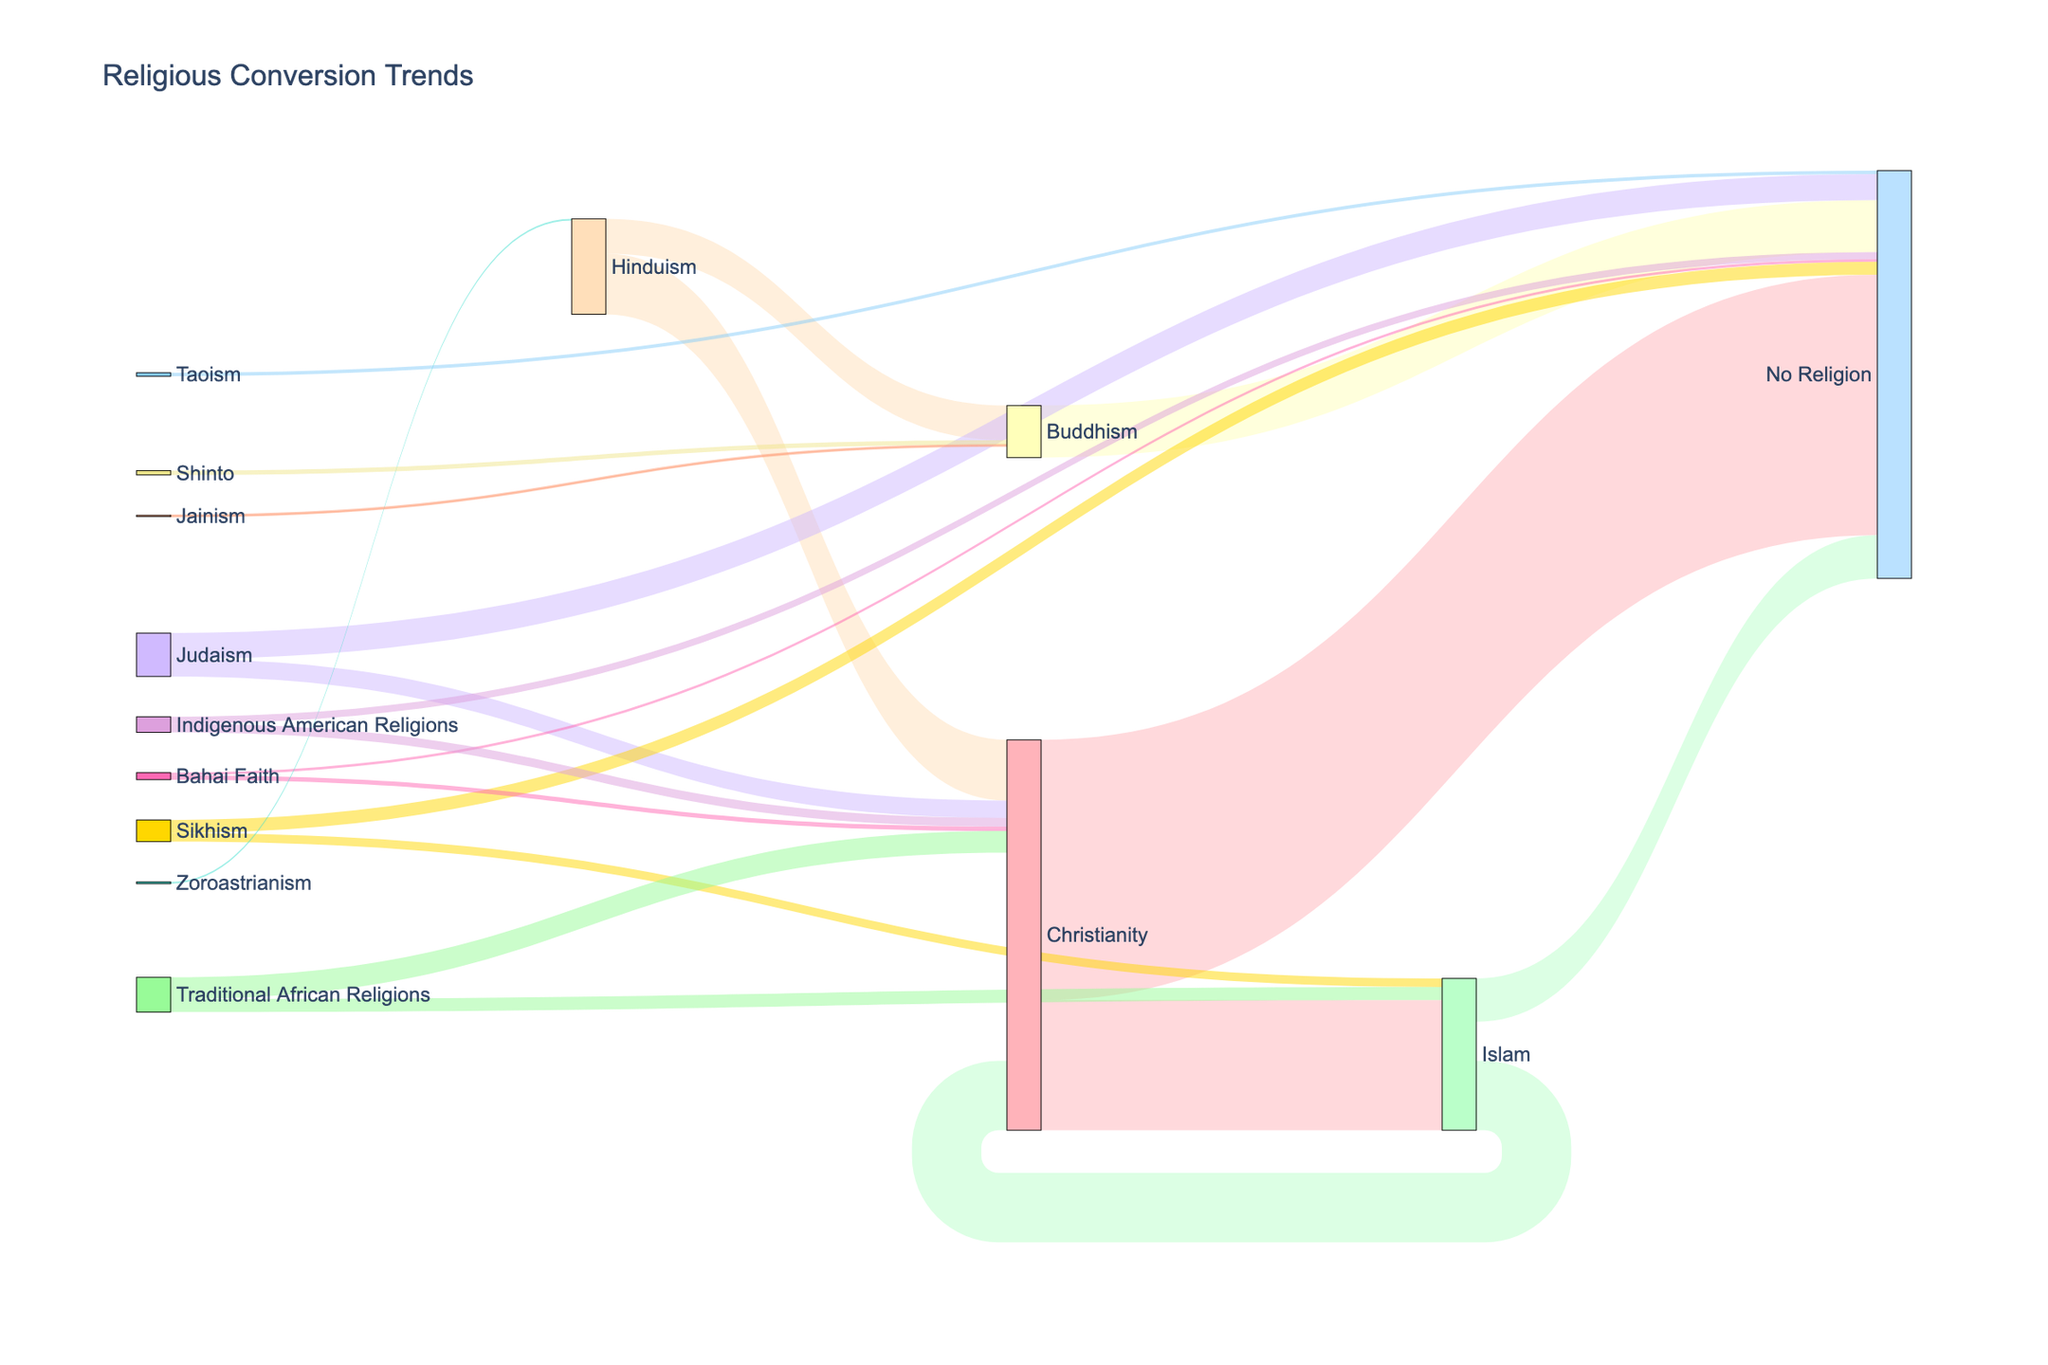What is the overall trend shown in the Sankey diagram? The Sankey diagram shows the flow of people converting from one religion to another. By analyzing the width of the lines (which represents the value of conversions), we can observe a significant trend of people leaving Christianity and Islam towards having "No Religion" as well as people moving within other religions like Buddhism and Zoroastrianism.
Answer: Conversions towards "No Religion" are prominent Which religion has the highest number of converts moving to "No Religion"? By looking at the width of the lines going to "No Religion", we see that Christianity has the highest number of people converting to "No Religion" because the line originating from Christianity to "No Religion" is the thickest.
Answer: Christianity How many people are converting from Islam to Christianity? Look at the width and the value labeled on the line flowing from Islam to Christianity. The figure shows that 80,000 people are converting from Islam to Christianity.
Answer: 80,000 Which religions have people converting to Buddhism? Analyze the diagram for lines that end at Buddhism. There are conversions from Hinduism, Shinto, and Jainism to Buddhism.
Answer: Hinduism, Shinto, Jainism What is the total number of people converting from Hinduism? To compute this, sum up all values of the outgoing lines from Hinduism. Hinduism has 70,000 converting to Christianity and 40,000 converting to Buddhism. The total is 70,000 + 40,000 = 110,000.
Answer: 110,000 Compare the number of people converting from Traditional African Religions to Christianity versus those converting to Islam. Inspect the widths and values of the lines moving from Traditional African Religions to Christianity and Islam. There are 25,000 converting to Christianity and 15,000 converting to Islam. 25,000 is greater than 15,000.
Answer: Christianity > Islam What are the two religions from which people most frequently convert to "No Religion"? Look at the lines ending at "No Religion" and compare their widths and values. The most significant lines are from Christianity (300,000) and Buddhism (60,000).
Answer: Christianity and Buddhism Which religion sees the most converts from the Indigenous American Religions? Identify the lines originating from Indigenous American Religions and compare them. The values are 10,000 to Christianity and 8,000 to "No Religion." The wider line goes to Christianity.
Answer: Christianity What is the total number of conversions flowing out of Sikhism? Sum the values of the lines flowing out of Sikhism. There are 15,000 to "No Religion" and 10,000 to Islam. Total is 15,000 + 10,000 = 25,000.
Answer: 25,000 How does the conversion rate from Judaism to "No Religion" compare to Judaism to Christianity? Analyze the widths and values of the lines proceeding from Judaism to "No Religion" and Judaism to Christianity. The conversion to "No Religion" is 30,000, and to Christianity is 20,000. 30,000 is greater than 20,000.
Answer: "No Religion" > Christianity 